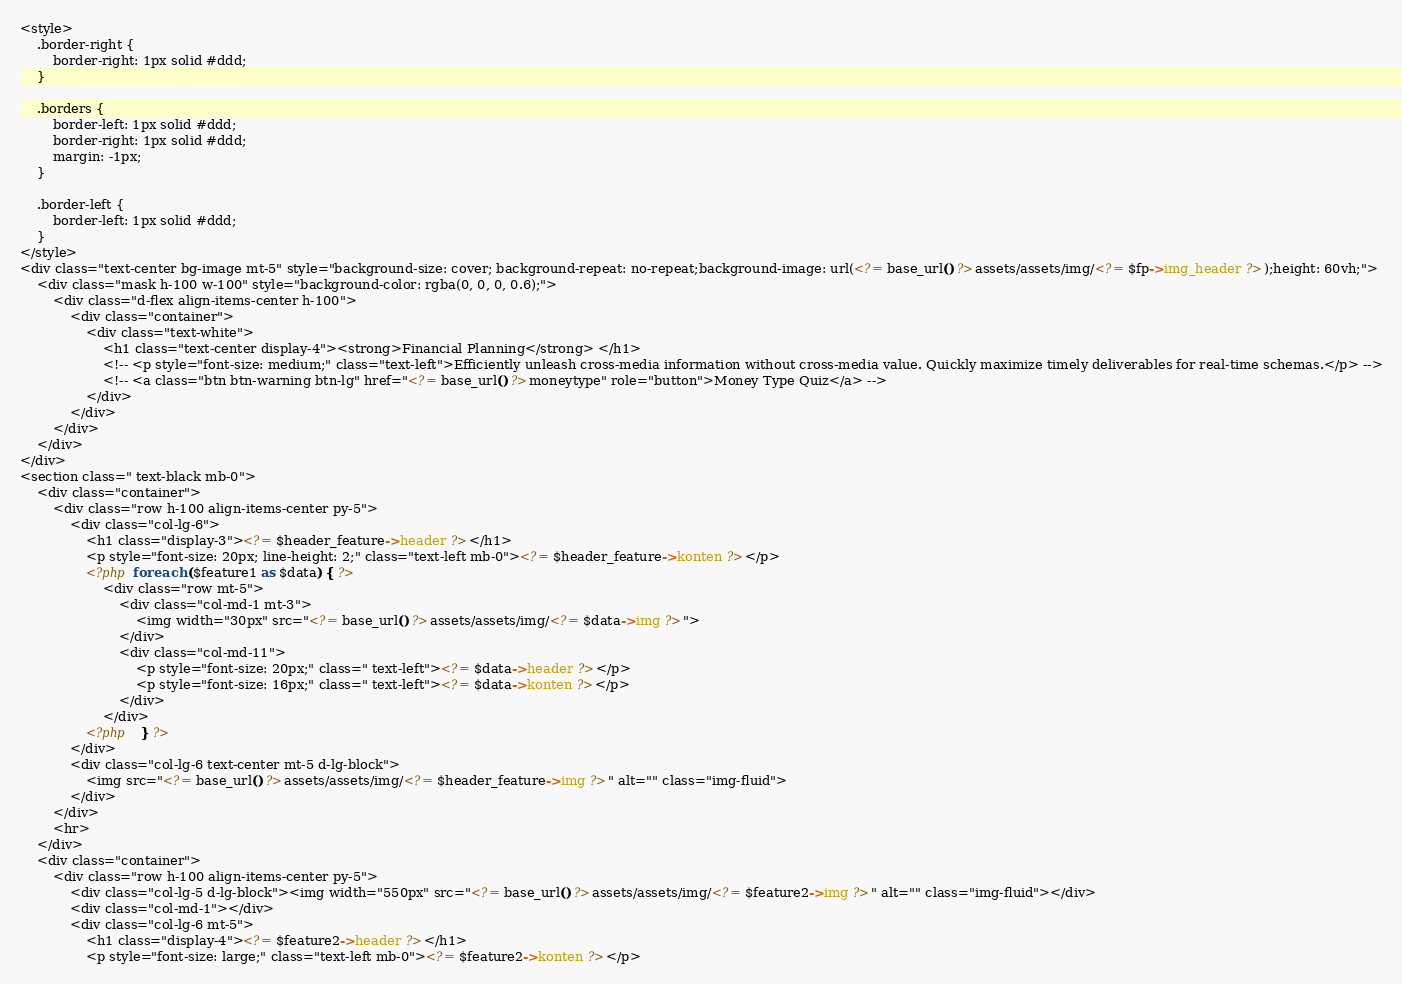Convert code to text. <code><loc_0><loc_0><loc_500><loc_500><_PHP_><style>
    .border-right {
        border-right: 1px solid #ddd;
    }

    .borders {
        border-left: 1px solid #ddd;
        border-right: 1px solid #ddd;
        margin: -1px;
    }

    .border-left {
        border-left: 1px solid #ddd;
    }
</style>
<div class="text-center bg-image mt-5" style="background-size: cover; background-repeat: no-repeat;background-image: url(<?= base_url() ?>assets/assets/img/<?= $fp->img_header ?>);height: 60vh;">
    <div class="mask h-100 w-100" style="background-color: rgba(0, 0, 0, 0.6);">
        <div class="d-flex align-items-center h-100">
            <div class="container">
                <div class="text-white">
                    <h1 class="text-center display-4"><strong>Financial Planning</strong> </h1>
                    <!-- <p style="font-size: medium;" class="text-left">Efficiently unleash cross-media information without cross-media value. Quickly maximize timely deliverables for real-time schemas.</p> -->
                    <!-- <a class="btn btn-warning btn-lg" href="<?= base_url() ?>moneytype" role="button">Money Type Quiz</a> -->
                </div>
            </div>
        </div>
    </div>
</div>
<section class=" text-black mb-0">
    <div class="container">
        <div class="row h-100 align-items-center py-5">
            <div class="col-lg-6">
                <h1 class="display-3"><?= $header_feature->header ?></h1>
                <p style="font-size: 20px; line-height: 2;" class="text-left mb-0"><?= $header_feature->konten ?></p>
                <?php foreach ($feature1 as $data) { ?>
                    <div class="row mt-5">
                        <div class="col-md-1 mt-3">
                            <img width="30px" src="<?= base_url() ?>assets/assets/img/<?= $data->img ?>">
                        </div>
                        <div class="col-md-11">
                            <p style="font-size: 20px;" class=" text-left"><?= $data->header ?></p>
                            <p style="font-size: 16px;" class=" text-left"><?= $data->konten ?></p>
                        </div>
                    </div>
                <?php   } ?>
            </div>
            <div class="col-lg-6 text-center mt-5 d-lg-block">
                <img src="<?= base_url() ?>assets/assets/img/<?= $header_feature->img ?>" alt="" class="img-fluid">
            </div>
        </div>
        <hr>
    </div>
    <div class="container">
        <div class="row h-100 align-items-center py-5">
            <div class="col-lg-5 d-lg-block"><img width="550px" src="<?= base_url() ?>assets/assets/img/<?= $feature2->img ?>" alt="" class="img-fluid"></div>
            <div class="col-md-1"></div>
            <div class="col-lg-6 mt-5">
                <h1 class="display-4"><?= $feature2->header ?></h1>
                <p style="font-size: large;" class="text-left mb-0"><?= $feature2->konten ?></p></code> 